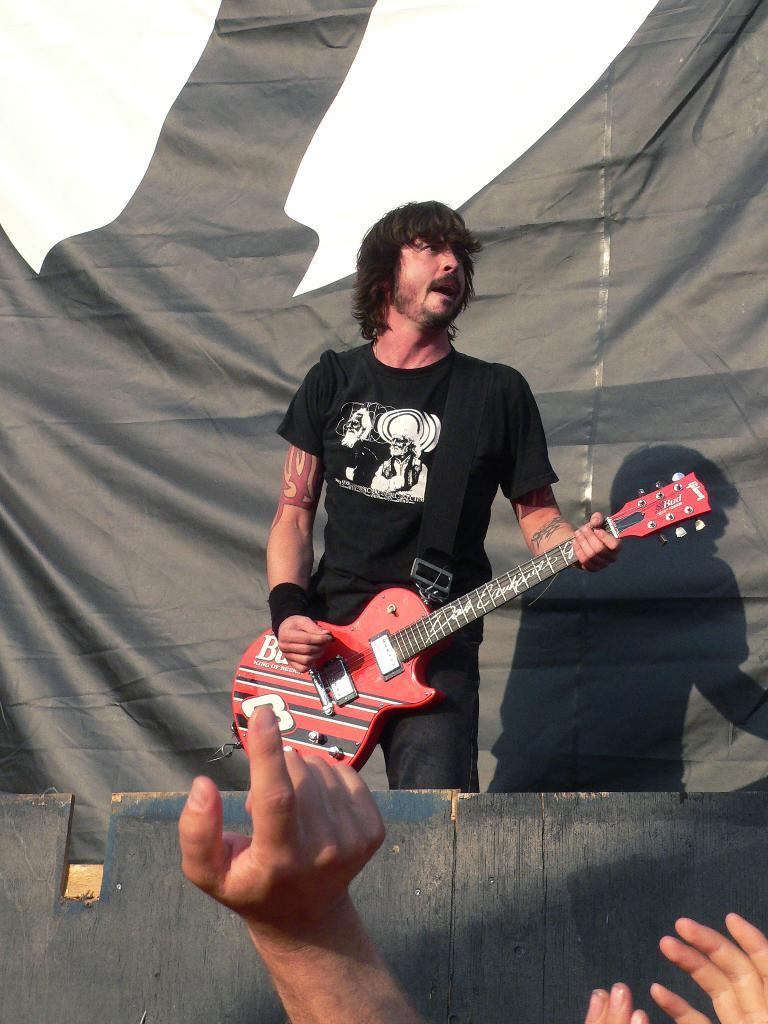What is the main subject of the image? There is a person in the image. What is the person holding in the image? The person is holding a guitar. What type of boot can be seen on the person's arm in the image? There is no boot visible on the person's arm in the image. How does the quiet atmosphere in the image affect the person's guitar playing? The image does not provide information about the atmosphere or the person's guitar playing, so it cannot be determined how the atmosphere might affect the person's guitar playing. 